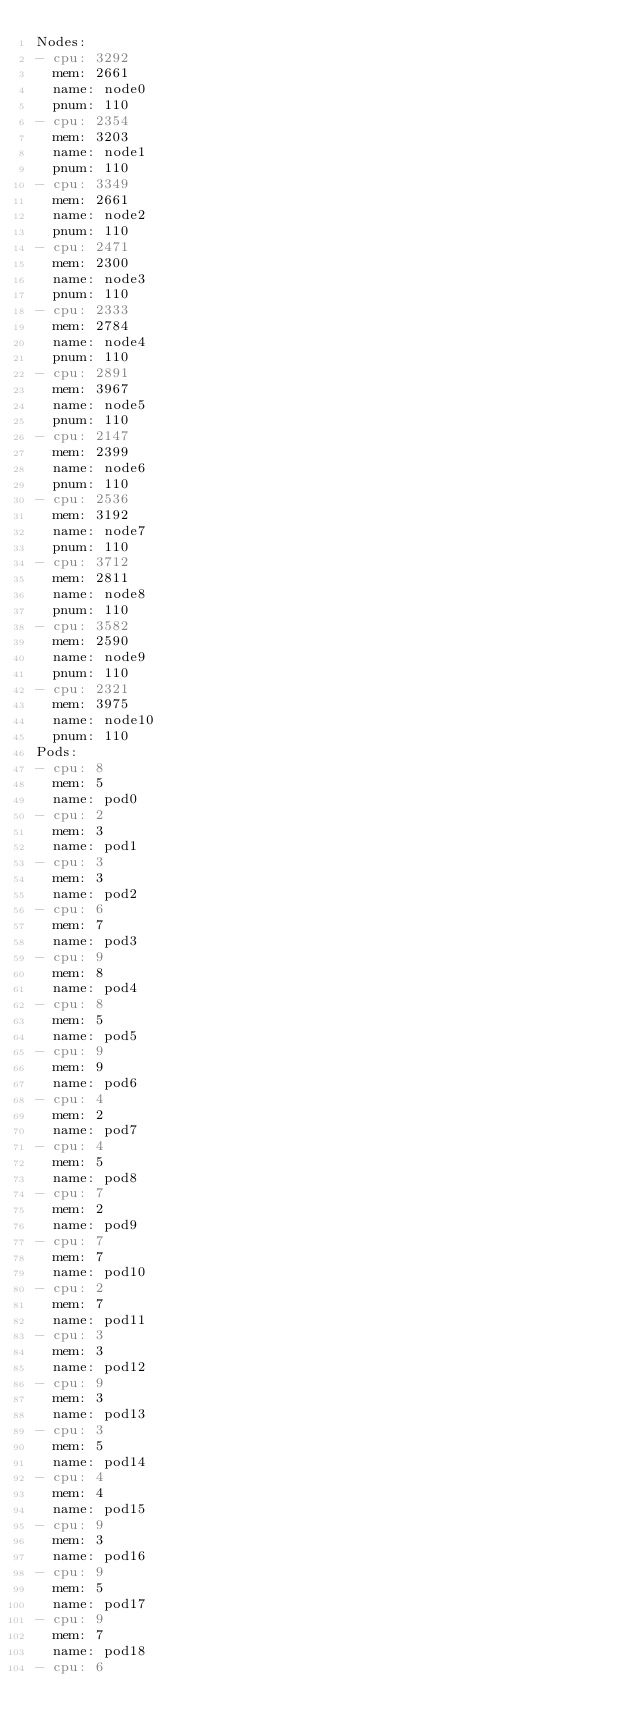<code> <loc_0><loc_0><loc_500><loc_500><_YAML_>Nodes:
- cpu: 3292
  mem: 2661
  name: node0
  pnum: 110
- cpu: 2354
  mem: 3203
  name: node1
  pnum: 110
- cpu: 3349
  mem: 2661
  name: node2
  pnum: 110
- cpu: 2471
  mem: 2300
  name: node3
  pnum: 110
- cpu: 2333
  mem: 2784
  name: node4
  pnum: 110
- cpu: 2891
  mem: 3967
  name: node5
  pnum: 110
- cpu: 2147
  mem: 2399
  name: node6
  pnum: 110
- cpu: 2536
  mem: 3192
  name: node7
  pnum: 110
- cpu: 3712
  mem: 2811
  name: node8
  pnum: 110
- cpu: 3582
  mem: 2590
  name: node9
  pnum: 110
- cpu: 2321
  mem: 3975
  name: node10
  pnum: 110
Pods:
- cpu: 8
  mem: 5
  name: pod0
- cpu: 2
  mem: 3
  name: pod1
- cpu: 3
  mem: 3
  name: pod2
- cpu: 6
  mem: 7
  name: pod3
- cpu: 9
  mem: 8
  name: pod4
- cpu: 8
  mem: 5
  name: pod5
- cpu: 9
  mem: 9
  name: pod6
- cpu: 4
  mem: 2
  name: pod7
- cpu: 4
  mem: 5
  name: pod8
- cpu: 7
  mem: 2
  name: pod9
- cpu: 7
  mem: 7
  name: pod10
- cpu: 2
  mem: 7
  name: pod11
- cpu: 3
  mem: 3
  name: pod12
- cpu: 9
  mem: 3
  name: pod13
- cpu: 3
  mem: 5
  name: pod14
- cpu: 4
  mem: 4
  name: pod15
- cpu: 9
  mem: 3
  name: pod16
- cpu: 9
  mem: 5
  name: pod17
- cpu: 9
  mem: 7
  name: pod18
- cpu: 6</code> 